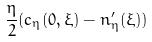<formula> <loc_0><loc_0><loc_500><loc_500>\frac { \eta } { 2 } ( c _ { \eta } ( 0 , \xi ) - n _ { \eta } ^ { \prime } ( \xi ) )</formula> 